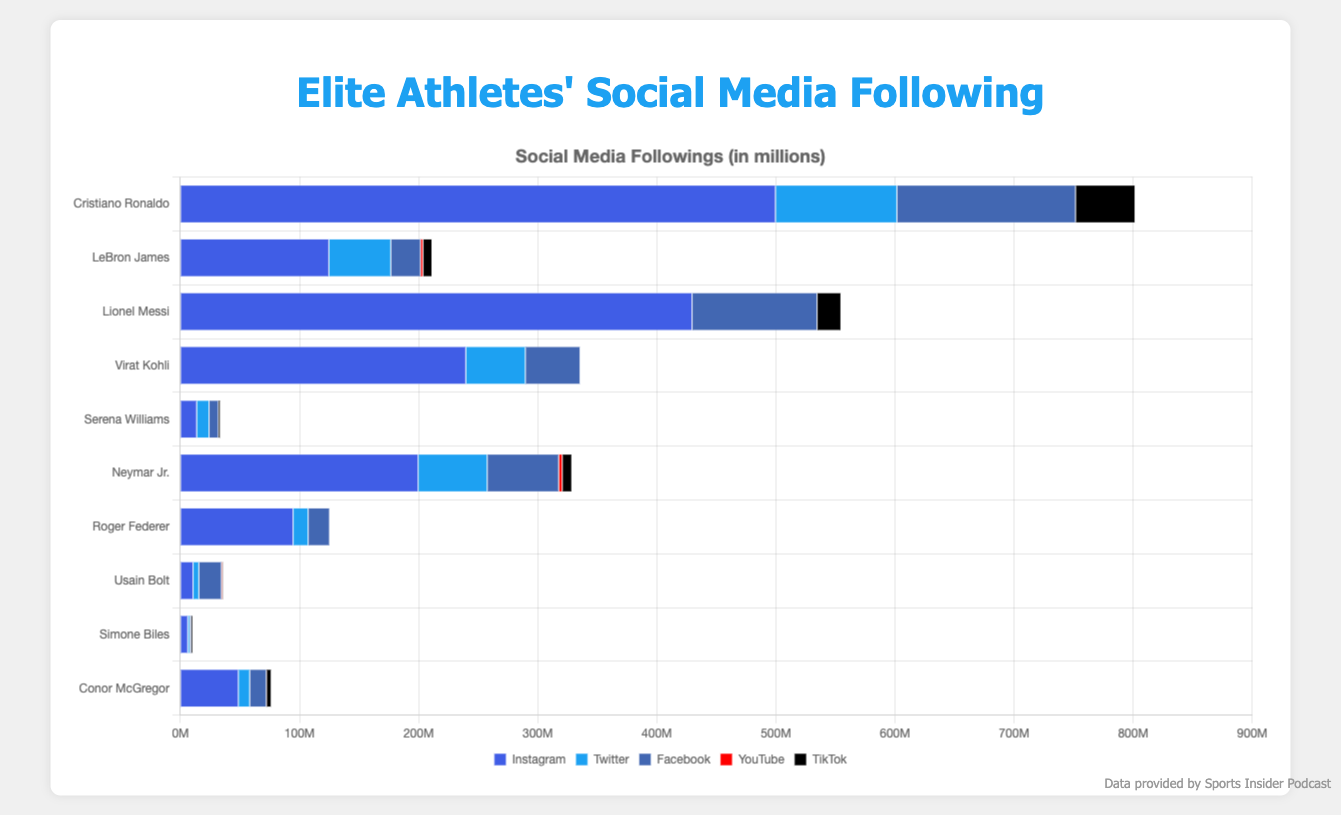Which athlete has the highest number of Instagram followers? To determine the athlete with the highest number of Instagram followers, look at the Instagram bar section for each athlete. Cristiano Ronaldo has the longest bar for Instagram with 500 million followers.
Answer: Cristiano Ronaldo Which platform does Lionel Messi use the least? By examining the bars corresponding to Lionel Messi, the platforms with zero followers are Twitter and YouTube. Both of these platforms are used the least since they have no followers.
Answer: Twitter and YouTube Among all the athletes, how many have over 100 million Facebook followers? Check each athlete's Facebook followers and count those over 100 million. Cristiano Ronaldo (150 million), Lionel Messi (105 million) each have over 100 million Facebook followers.
Answer: 2 athletes Compare the Instagram and Twitter followings of LeBron James. Which is greater and by how much? LeBron James has 125 million followers on Instagram and 52 million on Twitter. The difference is 125 million - 52 million = 73 million.
Answer: Instagram by 73 million What is the total number of YouTube followers for all athletes combined? Sum the YouTube followers for each athlete: LeBron James (2.1 million) + Neymar Jr. (3 million) + Usain Bolt (0.4 million) + Conor McGregor (0.1 million) = 5.6 million.
Answer: 5.6 million Who has the lowest following on TikTok and what is the number? By examining the TikTok segment for each athlete, Usain Bolt has the shortest bar with 500,000 followers.
Answer: Usain Bolt Which athlete has a greater total number of followers on all platforms combined, Serena Williams or Roger Federer? Sum the followings for each platform:
Serena Williams: 14M (Instagram) + 10.4M (Twitter) + 7.8M (Facebook) + 0 (YouTube) + 1.5M (TikTok) = 33.7M
Roger Federer: 95M (Instagram) + 12.6M (Twitter) + 18M (Facebook) + 0 (YouTube) + 0 (TikTok) = 125.6M
Roger Federer has a greater total following.
Answer: Roger Federer Which platform has the highest total followers across all athletes and what is the number? First, add up the followers for each platform:
Instagram: 500M + 125M + 430M + 240M + 14M + 200M + 95M + 11M + 6.5M + 49M = 1670.5M
Twitter: 102M + 52M + 0 + 50M + 10.4M + 58M + 12.6M + 4.8M + 1.6M + 9.5M = 300M
Facebook: 150M + 25M + 105M + 46M + 7.8M + 60M + 18M + 19M + 1.1M + 14M = 445.9M
YouTube: 0 + 2.1M + 0 + 0 + 0 + 3M + 0 + 0.4M + 0 + 0.1M = 5.6M
TikTok: 50M + 7.5M + 20M + 0 + 1.5M + 8M + 0 + 0.5M + 1.3M + 4M = 92.8M
Instagram has the highest total number of followers with 1670.5 million.
Answer: Instagram with 1670.5 million 